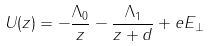Convert formula to latex. <formula><loc_0><loc_0><loc_500><loc_500>U ( z ) = - \frac { \Lambda _ { 0 } } { z } - \frac { \Lambda _ { 1 } } { z + d } + e E _ { \perp }</formula> 